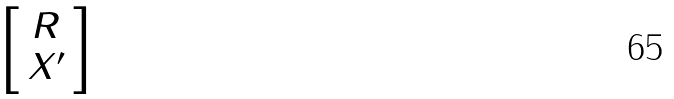Convert formula to latex. <formula><loc_0><loc_0><loc_500><loc_500>\begin{bmatrix} \ R \ \\ X ^ { \prime } \end{bmatrix}</formula> 